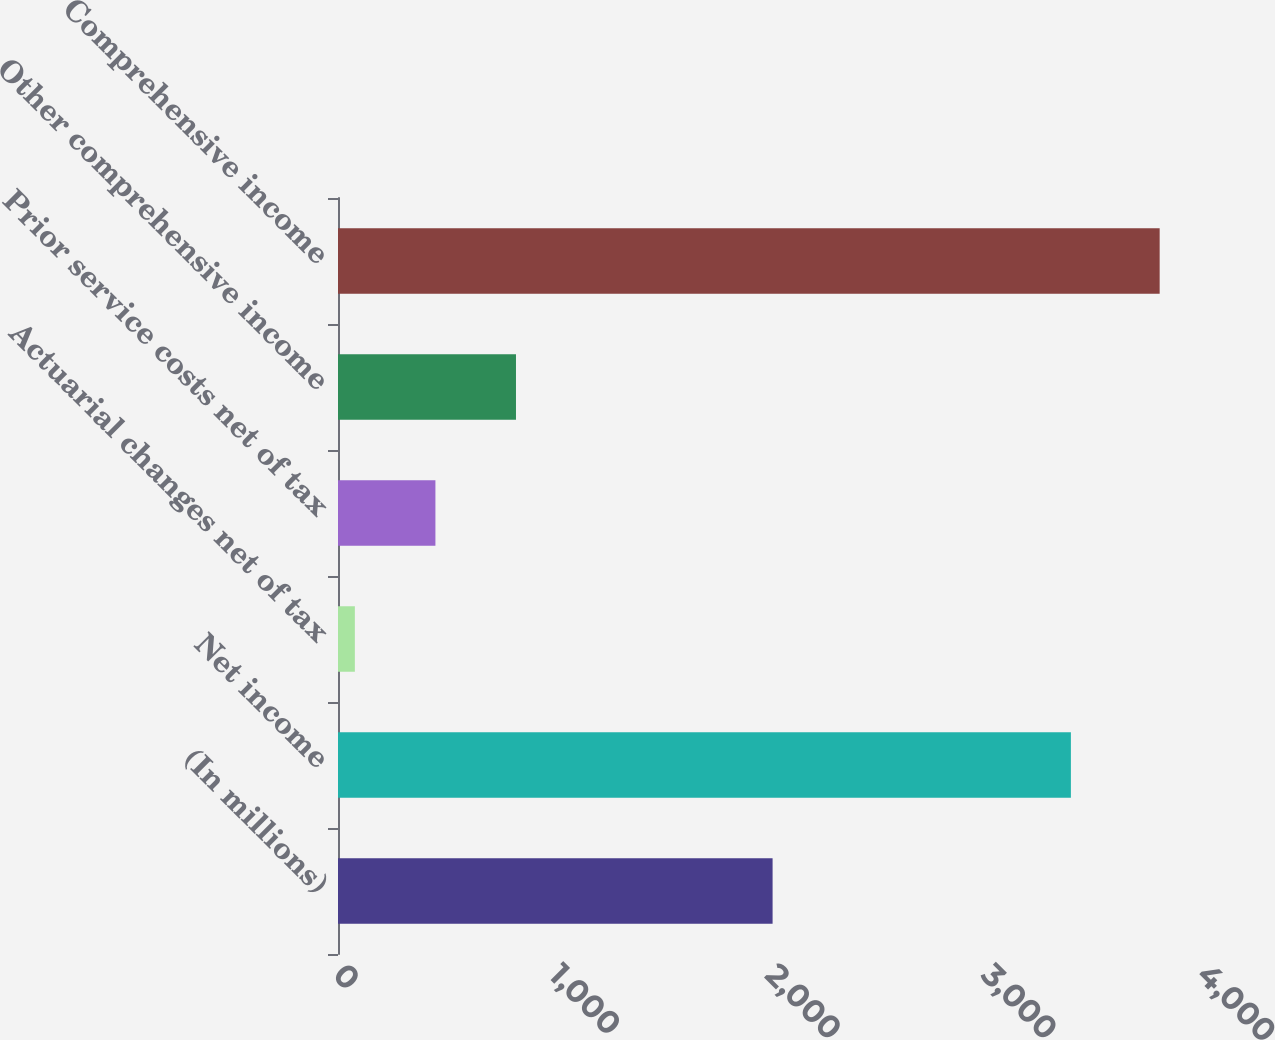Convert chart. <chart><loc_0><loc_0><loc_500><loc_500><bar_chart><fcel>(In millions)<fcel>Net income<fcel>Actuarial changes net of tax<fcel>Prior service costs net of tax<fcel>Other comprehensive income<fcel>Comprehensive income<nl><fcel>2012<fcel>3393<fcel>78<fcel>451<fcel>824<fcel>3804<nl></chart> 